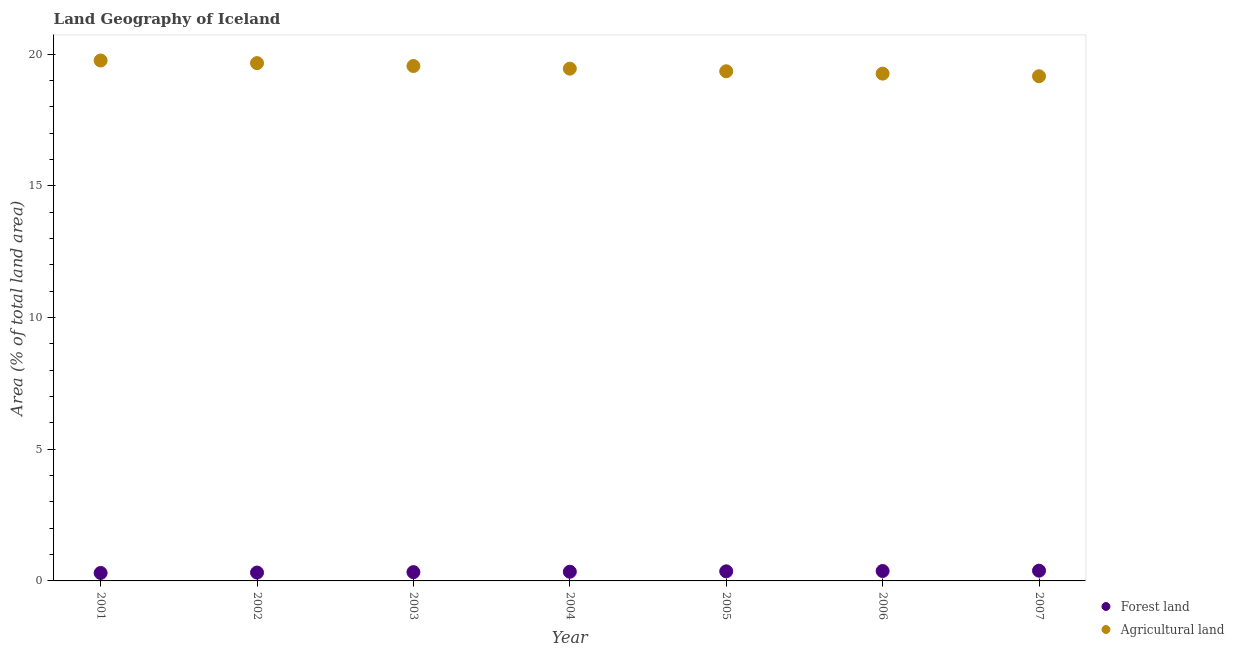Is the number of dotlines equal to the number of legend labels?
Your response must be concise. Yes. What is the percentage of land area under agriculture in 2003?
Your response must be concise. 19.55. Across all years, what is the maximum percentage of land area under agriculture?
Your answer should be very brief. 19.76. Across all years, what is the minimum percentage of land area under forests?
Your answer should be compact. 0.3. In which year was the percentage of land area under forests minimum?
Offer a very short reply. 2001. What is the total percentage of land area under forests in the graph?
Keep it short and to the point. 2.43. What is the difference between the percentage of land area under agriculture in 2005 and that in 2006?
Provide a succinct answer. 0.09. What is the difference between the percentage of land area under forests in 2005 and the percentage of land area under agriculture in 2004?
Provide a succinct answer. -19.09. What is the average percentage of land area under agriculture per year?
Your response must be concise. 19.46. In the year 2007, what is the difference between the percentage of land area under forests and percentage of land area under agriculture?
Your answer should be compact. -18.77. What is the ratio of the percentage of land area under forests in 2003 to that in 2007?
Provide a succinct answer. 0.86. Is the percentage of land area under forests in 2005 less than that in 2006?
Offer a very short reply. Yes. Is the difference between the percentage of land area under agriculture in 2003 and 2004 greater than the difference between the percentage of land area under forests in 2003 and 2004?
Keep it short and to the point. Yes. What is the difference between the highest and the second highest percentage of land area under agriculture?
Make the answer very short. 0.1. What is the difference between the highest and the lowest percentage of land area under agriculture?
Your answer should be compact. 0.6. In how many years, is the percentage of land area under agriculture greater than the average percentage of land area under agriculture taken over all years?
Your answer should be very brief. 3. Does the percentage of land area under agriculture monotonically increase over the years?
Your answer should be compact. No. Is the percentage of land area under forests strictly less than the percentage of land area under agriculture over the years?
Offer a terse response. Yes. How many dotlines are there?
Your answer should be very brief. 2. What is the difference between two consecutive major ticks on the Y-axis?
Provide a succinct answer. 5. Are the values on the major ticks of Y-axis written in scientific E-notation?
Offer a very short reply. No. Does the graph contain grids?
Offer a terse response. No. Where does the legend appear in the graph?
Your answer should be very brief. Bottom right. How are the legend labels stacked?
Offer a terse response. Vertical. What is the title of the graph?
Offer a terse response. Land Geography of Iceland. Does "Private consumption" appear as one of the legend labels in the graph?
Your response must be concise. No. What is the label or title of the X-axis?
Your response must be concise. Year. What is the label or title of the Y-axis?
Ensure brevity in your answer.  Area (% of total land area). What is the Area (% of total land area) in Forest land in 2001?
Your answer should be very brief. 0.3. What is the Area (% of total land area) of Agricultural land in 2001?
Your response must be concise. 19.76. What is the Area (% of total land area) of Forest land in 2002?
Provide a succinct answer. 0.32. What is the Area (% of total land area) of Agricultural land in 2002?
Offer a very short reply. 19.66. What is the Area (% of total land area) of Forest land in 2003?
Make the answer very short. 0.33. What is the Area (% of total land area) of Agricultural land in 2003?
Your response must be concise. 19.55. What is the Area (% of total land area) in Forest land in 2004?
Ensure brevity in your answer.  0.35. What is the Area (% of total land area) of Agricultural land in 2004?
Make the answer very short. 19.45. What is the Area (% of total land area) of Forest land in 2005?
Offer a terse response. 0.36. What is the Area (% of total land area) in Agricultural land in 2005?
Provide a succinct answer. 19.35. What is the Area (% of total land area) of Forest land in 2006?
Your response must be concise. 0.38. What is the Area (% of total land area) of Agricultural land in 2006?
Offer a very short reply. 19.26. What is the Area (% of total land area) of Forest land in 2007?
Give a very brief answer. 0.39. What is the Area (% of total land area) in Agricultural land in 2007?
Provide a short and direct response. 19.16. Across all years, what is the maximum Area (% of total land area) in Forest land?
Your response must be concise. 0.39. Across all years, what is the maximum Area (% of total land area) in Agricultural land?
Provide a short and direct response. 19.76. Across all years, what is the minimum Area (% of total land area) of Forest land?
Your answer should be compact. 0.3. Across all years, what is the minimum Area (% of total land area) in Agricultural land?
Offer a very short reply. 19.16. What is the total Area (% of total land area) in Forest land in the graph?
Offer a very short reply. 2.43. What is the total Area (% of total land area) in Agricultural land in the graph?
Give a very brief answer. 136.2. What is the difference between the Area (% of total land area) of Forest land in 2001 and that in 2002?
Make the answer very short. -0.02. What is the difference between the Area (% of total land area) in Agricultural land in 2001 and that in 2002?
Provide a succinct answer. 0.1. What is the difference between the Area (% of total land area) of Forest land in 2001 and that in 2003?
Keep it short and to the point. -0.03. What is the difference between the Area (% of total land area) of Agricultural land in 2001 and that in 2003?
Give a very brief answer. 0.21. What is the difference between the Area (% of total land area) in Forest land in 2001 and that in 2004?
Provide a succinct answer. -0.05. What is the difference between the Area (% of total land area) in Agricultural land in 2001 and that in 2004?
Offer a terse response. 0.31. What is the difference between the Area (% of total land area) in Forest land in 2001 and that in 2005?
Your answer should be compact. -0.06. What is the difference between the Area (% of total land area) of Agricultural land in 2001 and that in 2005?
Your response must be concise. 0.41. What is the difference between the Area (% of total land area) in Forest land in 2001 and that in 2006?
Your response must be concise. -0.07. What is the difference between the Area (% of total land area) of Agricultural land in 2001 and that in 2006?
Provide a succinct answer. 0.5. What is the difference between the Area (% of total land area) of Forest land in 2001 and that in 2007?
Offer a terse response. -0.09. What is the difference between the Area (% of total land area) of Agricultural land in 2001 and that in 2007?
Provide a short and direct response. 0.6. What is the difference between the Area (% of total land area) of Forest land in 2002 and that in 2003?
Ensure brevity in your answer.  -0.02. What is the difference between the Area (% of total land area) in Agricultural land in 2002 and that in 2003?
Keep it short and to the point. 0.11. What is the difference between the Area (% of total land area) in Forest land in 2002 and that in 2004?
Provide a short and direct response. -0.03. What is the difference between the Area (% of total land area) of Agricultural land in 2002 and that in 2004?
Your answer should be very brief. 0.21. What is the difference between the Area (% of total land area) in Forest land in 2002 and that in 2005?
Give a very brief answer. -0.05. What is the difference between the Area (% of total land area) of Agricultural land in 2002 and that in 2005?
Your answer should be very brief. 0.31. What is the difference between the Area (% of total land area) of Forest land in 2002 and that in 2006?
Your answer should be very brief. -0.06. What is the difference between the Area (% of total land area) in Agricultural land in 2002 and that in 2006?
Give a very brief answer. 0.4. What is the difference between the Area (% of total land area) in Forest land in 2002 and that in 2007?
Ensure brevity in your answer.  -0.07. What is the difference between the Area (% of total land area) in Agricultural land in 2002 and that in 2007?
Your answer should be compact. 0.5. What is the difference between the Area (% of total land area) of Forest land in 2003 and that in 2004?
Provide a short and direct response. -0.02. What is the difference between the Area (% of total land area) in Agricultural land in 2003 and that in 2004?
Offer a terse response. 0.1. What is the difference between the Area (% of total land area) in Forest land in 2003 and that in 2005?
Your answer should be very brief. -0.03. What is the difference between the Area (% of total land area) of Agricultural land in 2003 and that in 2005?
Provide a short and direct response. 0.2. What is the difference between the Area (% of total land area) of Forest land in 2003 and that in 2006?
Offer a very short reply. -0.04. What is the difference between the Area (% of total land area) of Agricultural land in 2003 and that in 2006?
Your answer should be very brief. 0.29. What is the difference between the Area (% of total land area) of Forest land in 2003 and that in 2007?
Offer a very short reply. -0.06. What is the difference between the Area (% of total land area) in Agricultural land in 2003 and that in 2007?
Provide a short and direct response. 0.39. What is the difference between the Area (% of total land area) in Forest land in 2004 and that in 2005?
Your answer should be compact. -0.02. What is the difference between the Area (% of total land area) of Agricultural land in 2004 and that in 2005?
Make the answer very short. 0.1. What is the difference between the Area (% of total land area) of Forest land in 2004 and that in 2006?
Offer a terse response. -0.03. What is the difference between the Area (% of total land area) in Agricultural land in 2004 and that in 2006?
Give a very brief answer. 0.19. What is the difference between the Area (% of total land area) of Forest land in 2004 and that in 2007?
Your answer should be very brief. -0.04. What is the difference between the Area (% of total land area) of Agricultural land in 2004 and that in 2007?
Your response must be concise. 0.29. What is the difference between the Area (% of total land area) in Forest land in 2005 and that in 2006?
Ensure brevity in your answer.  -0.01. What is the difference between the Area (% of total land area) in Agricultural land in 2005 and that in 2006?
Offer a terse response. 0.09. What is the difference between the Area (% of total land area) in Forest land in 2005 and that in 2007?
Ensure brevity in your answer.  -0.02. What is the difference between the Area (% of total land area) in Agricultural land in 2005 and that in 2007?
Make the answer very short. 0.19. What is the difference between the Area (% of total land area) in Forest land in 2006 and that in 2007?
Make the answer very short. -0.01. What is the difference between the Area (% of total land area) in Agricultural land in 2006 and that in 2007?
Give a very brief answer. 0.1. What is the difference between the Area (% of total land area) of Forest land in 2001 and the Area (% of total land area) of Agricultural land in 2002?
Your response must be concise. -19.36. What is the difference between the Area (% of total land area) of Forest land in 2001 and the Area (% of total land area) of Agricultural land in 2003?
Provide a succinct answer. -19.25. What is the difference between the Area (% of total land area) of Forest land in 2001 and the Area (% of total land area) of Agricultural land in 2004?
Your response must be concise. -19.15. What is the difference between the Area (% of total land area) of Forest land in 2001 and the Area (% of total land area) of Agricultural land in 2005?
Offer a very short reply. -19.05. What is the difference between the Area (% of total land area) of Forest land in 2001 and the Area (% of total land area) of Agricultural land in 2006?
Make the answer very short. -18.96. What is the difference between the Area (% of total land area) of Forest land in 2001 and the Area (% of total land area) of Agricultural land in 2007?
Your answer should be compact. -18.86. What is the difference between the Area (% of total land area) in Forest land in 2002 and the Area (% of total land area) in Agricultural land in 2003?
Your answer should be very brief. -19.23. What is the difference between the Area (% of total land area) of Forest land in 2002 and the Area (% of total land area) of Agricultural land in 2004?
Offer a very short reply. -19.13. What is the difference between the Area (% of total land area) in Forest land in 2002 and the Area (% of total land area) in Agricultural land in 2005?
Your response must be concise. -19.03. What is the difference between the Area (% of total land area) in Forest land in 2002 and the Area (% of total land area) in Agricultural land in 2006?
Your response must be concise. -18.94. What is the difference between the Area (% of total land area) in Forest land in 2002 and the Area (% of total land area) in Agricultural land in 2007?
Your answer should be compact. -18.84. What is the difference between the Area (% of total land area) in Forest land in 2003 and the Area (% of total land area) in Agricultural land in 2004?
Make the answer very short. -19.12. What is the difference between the Area (% of total land area) in Forest land in 2003 and the Area (% of total land area) in Agricultural land in 2005?
Your response must be concise. -19.02. What is the difference between the Area (% of total land area) of Forest land in 2003 and the Area (% of total land area) of Agricultural land in 2006?
Provide a succinct answer. -18.93. What is the difference between the Area (% of total land area) in Forest land in 2003 and the Area (% of total land area) in Agricultural land in 2007?
Ensure brevity in your answer.  -18.83. What is the difference between the Area (% of total land area) of Forest land in 2004 and the Area (% of total land area) of Agricultural land in 2005?
Your answer should be very brief. -19. What is the difference between the Area (% of total land area) of Forest land in 2004 and the Area (% of total land area) of Agricultural land in 2006?
Offer a very short reply. -18.91. What is the difference between the Area (% of total land area) in Forest land in 2004 and the Area (% of total land area) in Agricultural land in 2007?
Offer a terse response. -18.81. What is the difference between the Area (% of total land area) of Forest land in 2005 and the Area (% of total land area) of Agricultural land in 2006?
Make the answer very short. -18.9. What is the difference between the Area (% of total land area) in Forest land in 2005 and the Area (% of total land area) in Agricultural land in 2007?
Your response must be concise. -18.8. What is the difference between the Area (% of total land area) of Forest land in 2006 and the Area (% of total land area) of Agricultural land in 2007?
Offer a terse response. -18.79. What is the average Area (% of total land area) of Forest land per year?
Your answer should be very brief. 0.35. What is the average Area (% of total land area) of Agricultural land per year?
Keep it short and to the point. 19.46. In the year 2001, what is the difference between the Area (% of total land area) in Forest land and Area (% of total land area) in Agricultural land?
Keep it short and to the point. -19.46. In the year 2002, what is the difference between the Area (% of total land area) of Forest land and Area (% of total land area) of Agricultural land?
Your answer should be compact. -19.34. In the year 2003, what is the difference between the Area (% of total land area) in Forest land and Area (% of total land area) in Agricultural land?
Provide a short and direct response. -19.22. In the year 2004, what is the difference between the Area (% of total land area) of Forest land and Area (% of total land area) of Agricultural land?
Provide a succinct answer. -19.1. In the year 2005, what is the difference between the Area (% of total land area) of Forest land and Area (% of total land area) of Agricultural land?
Make the answer very short. -18.99. In the year 2006, what is the difference between the Area (% of total land area) of Forest land and Area (% of total land area) of Agricultural land?
Give a very brief answer. -18.89. In the year 2007, what is the difference between the Area (% of total land area) in Forest land and Area (% of total land area) in Agricultural land?
Provide a succinct answer. -18.77. What is the ratio of the Area (% of total land area) in Forest land in 2001 to that in 2002?
Provide a short and direct response. 0.95. What is the ratio of the Area (% of total land area) in Agricultural land in 2001 to that in 2002?
Provide a succinct answer. 1.01. What is the ratio of the Area (% of total land area) of Forest land in 2001 to that in 2003?
Provide a short and direct response. 0.91. What is the ratio of the Area (% of total land area) of Agricultural land in 2001 to that in 2003?
Make the answer very short. 1.01. What is the ratio of the Area (% of total land area) of Forest land in 2001 to that in 2004?
Make the answer very short. 0.87. What is the ratio of the Area (% of total land area) of Agricultural land in 2001 to that in 2004?
Give a very brief answer. 1.02. What is the ratio of the Area (% of total land area) in Forest land in 2001 to that in 2005?
Make the answer very short. 0.83. What is the ratio of the Area (% of total land area) in Agricultural land in 2001 to that in 2005?
Offer a very short reply. 1.02. What is the ratio of the Area (% of total land area) of Forest land in 2001 to that in 2006?
Offer a terse response. 0.8. What is the ratio of the Area (% of total land area) of Agricultural land in 2001 to that in 2006?
Make the answer very short. 1.03. What is the ratio of the Area (% of total land area) in Forest land in 2001 to that in 2007?
Your answer should be very brief. 0.78. What is the ratio of the Area (% of total land area) of Agricultural land in 2001 to that in 2007?
Your answer should be very brief. 1.03. What is the ratio of the Area (% of total land area) in Forest land in 2002 to that in 2003?
Offer a terse response. 0.95. What is the ratio of the Area (% of total land area) in Agricultural land in 2002 to that in 2003?
Provide a succinct answer. 1.01. What is the ratio of the Area (% of total land area) in Forest land in 2002 to that in 2004?
Provide a succinct answer. 0.91. What is the ratio of the Area (% of total land area) of Agricultural land in 2002 to that in 2004?
Make the answer very short. 1.01. What is the ratio of the Area (% of total land area) of Forest land in 2002 to that in 2005?
Your answer should be very brief. 0.87. What is the ratio of the Area (% of total land area) of Agricultural land in 2002 to that in 2005?
Your answer should be compact. 1.02. What is the ratio of the Area (% of total land area) in Forest land in 2002 to that in 2006?
Provide a succinct answer. 0.84. What is the ratio of the Area (% of total land area) in Agricultural land in 2002 to that in 2006?
Offer a very short reply. 1.02. What is the ratio of the Area (% of total land area) of Forest land in 2002 to that in 2007?
Make the answer very short. 0.82. What is the ratio of the Area (% of total land area) of Agricultural land in 2002 to that in 2007?
Provide a short and direct response. 1.03. What is the ratio of the Area (% of total land area) of Forest land in 2003 to that in 2004?
Your response must be concise. 0.96. What is the ratio of the Area (% of total land area) of Forest land in 2003 to that in 2005?
Your answer should be compact. 0.92. What is the ratio of the Area (% of total land area) of Agricultural land in 2003 to that in 2005?
Your response must be concise. 1.01. What is the ratio of the Area (% of total land area) of Forest land in 2003 to that in 2006?
Give a very brief answer. 0.89. What is the ratio of the Area (% of total land area) of Forest land in 2003 to that in 2007?
Your answer should be compact. 0.86. What is the ratio of the Area (% of total land area) of Agricultural land in 2003 to that in 2007?
Your answer should be compact. 1.02. What is the ratio of the Area (% of total land area) in Forest land in 2004 to that in 2005?
Your answer should be very brief. 0.96. What is the ratio of the Area (% of total land area) in Agricultural land in 2004 to that in 2005?
Your answer should be compact. 1.01. What is the ratio of the Area (% of total land area) of Forest land in 2004 to that in 2006?
Your answer should be very brief. 0.93. What is the ratio of the Area (% of total land area) of Agricultural land in 2004 to that in 2006?
Ensure brevity in your answer.  1.01. What is the ratio of the Area (% of total land area) of Forest land in 2004 to that in 2007?
Give a very brief answer. 0.9. What is the ratio of the Area (% of total land area) of Agricultural land in 2004 to that in 2007?
Provide a succinct answer. 1.02. What is the ratio of the Area (% of total land area) in Forest land in 2005 to that in 2006?
Your answer should be compact. 0.97. What is the ratio of the Area (% of total land area) in Forest land in 2005 to that in 2007?
Your answer should be very brief. 0.94. What is the ratio of the Area (% of total land area) in Agricultural land in 2005 to that in 2007?
Your answer should be very brief. 1.01. What is the ratio of the Area (% of total land area) in Forest land in 2006 to that in 2007?
Your answer should be very brief. 0.97. What is the ratio of the Area (% of total land area) of Agricultural land in 2006 to that in 2007?
Make the answer very short. 1.01. What is the difference between the highest and the second highest Area (% of total land area) in Forest land?
Provide a short and direct response. 0.01. What is the difference between the highest and the second highest Area (% of total land area) in Agricultural land?
Offer a very short reply. 0.1. What is the difference between the highest and the lowest Area (% of total land area) in Forest land?
Your response must be concise. 0.09. What is the difference between the highest and the lowest Area (% of total land area) of Agricultural land?
Offer a terse response. 0.6. 